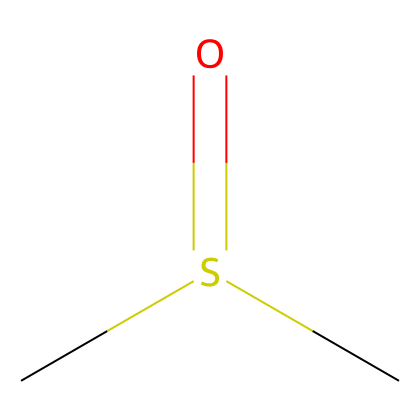what is the molecular formula of this compound? The SMILES representation shows one sulfur (S), two carbon (C), and one oxygen (O) atom in the chemical structure. Therefore, the molecular formula can be derived directly from the count of these elements.
Answer: C2H6O how many total hydrogen atoms are in this compound? The SMILES representation indicates two carbon atoms each typically bonded to three hydrogen atoms, resulting in six hydrogen atoms total; no hydrogens are lost due to double bonding in this structure.
Answer: 6 what type of bond is between the sulfur and oxygen atoms? In the SMILES structure, the oxygen (O) is connected to the sulfur (S) by a double bond, indicated by the '=' sign. This signifies a significant bond strength characteristic of sulfur oxides.
Answer: double bond which functional group does dimethyl sulfoxide belong to? The structure shows the presence of a sulfonyl group (R-S(=O)-R), which is indicative of sulfoxides. This functional group is characteristic of organosulfur compounds.
Answer: sulfoxide is dimethyl sulfoxide a polar or nonpolar solvent? The presence of the oxygen atom creating a polar bond with sulfur and the overall electronegativity differences indicate that DMSO is a polar solvent, allowing it to dissolve a variety of compounds.
Answer: polar how many atoms are there in total in the molecular structure? The structure contains a total of five atoms: two carbon (C), one sulfur (S), and one oxygen (O), plus the requisite hydrogen atoms. Counting these together gives us five.
Answer: 5 